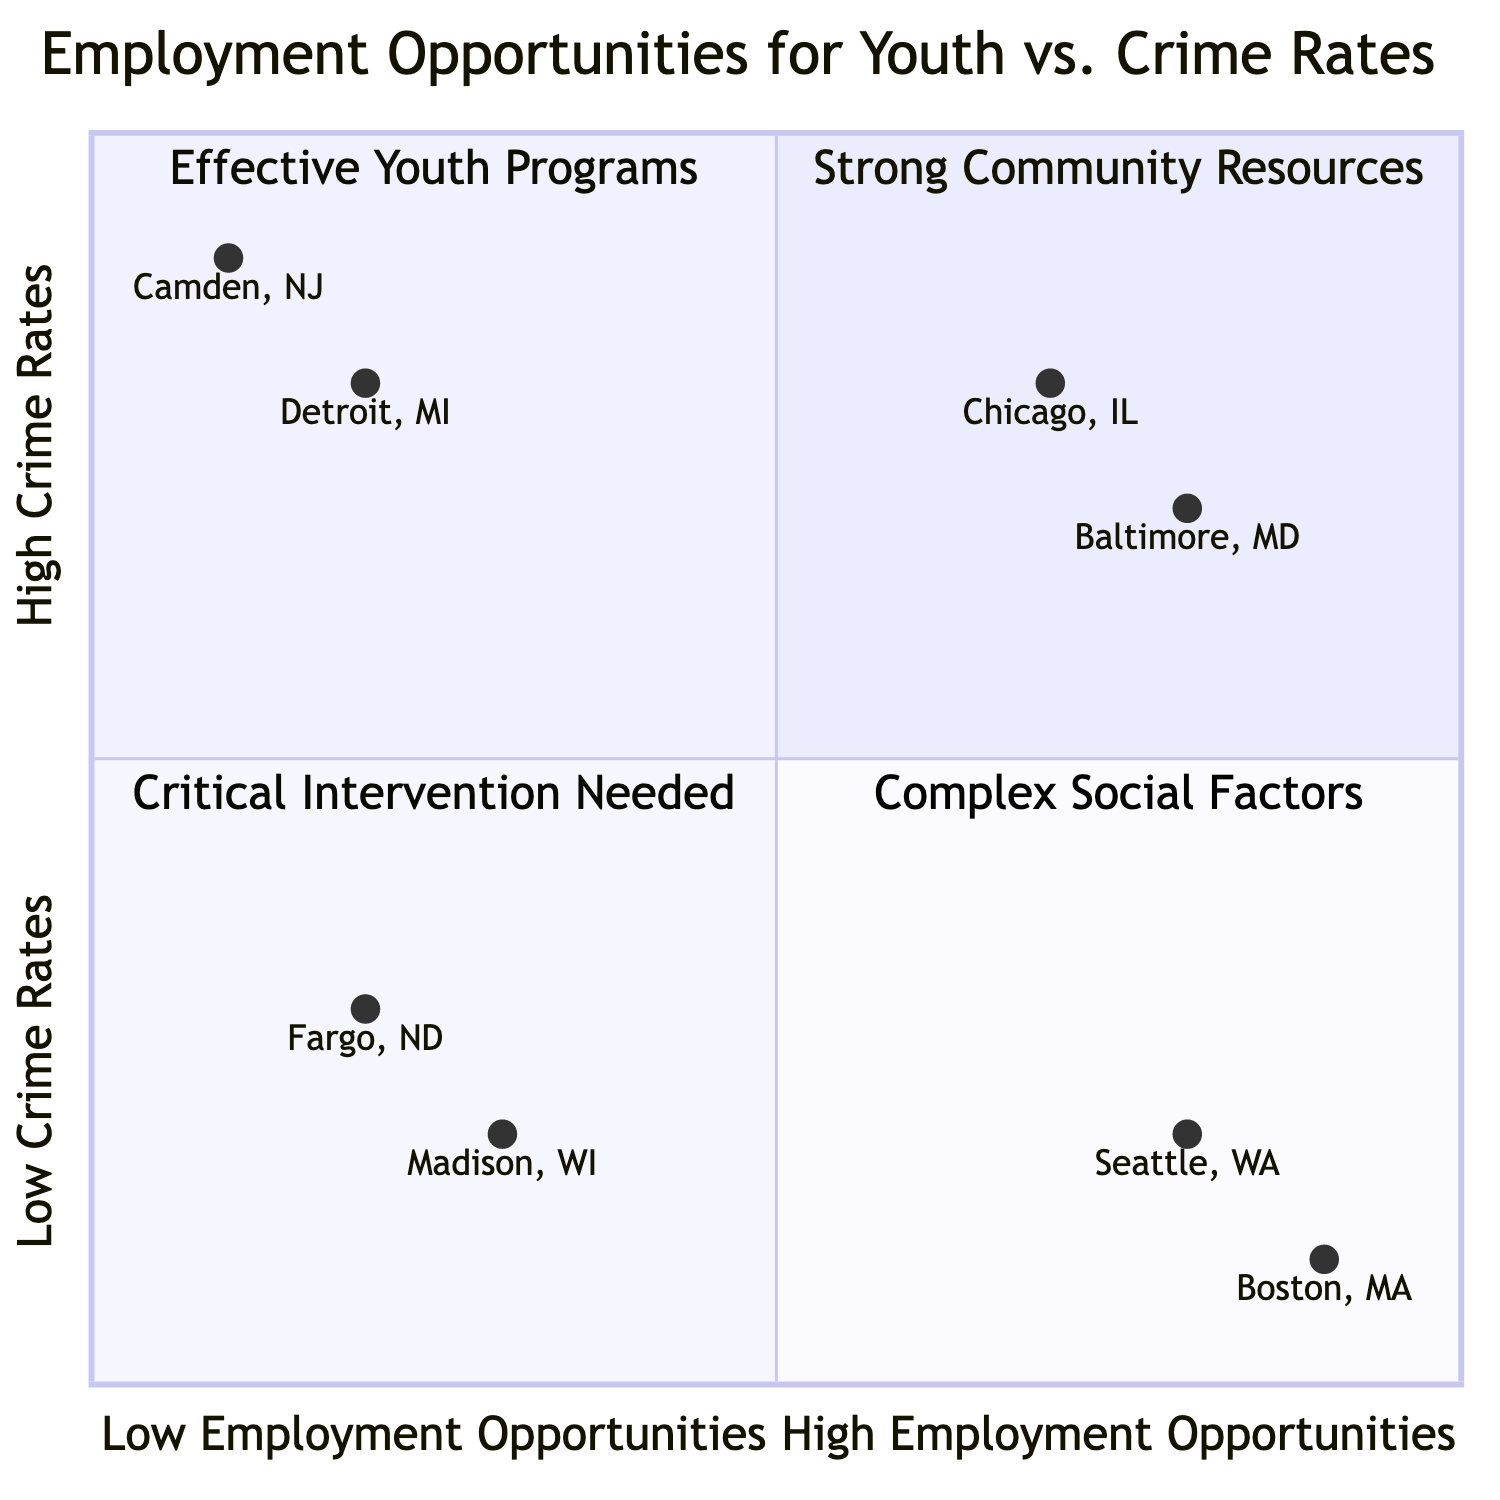What locations have high employment opportunities and low crime rates? The diagram indicates that Seattle, WA, and Boston, MA, fall into the quadrant with high employment opportunities and low crime rates, highlighting their effective youth employment programs.
Answer: Seattle, WA; Boston, MA How many areas fall into the "Low Employment Opportunities, High Crime Rates" quadrant? The diagram depicts two locations, Camden, NJ, and Detroit, MI, which are classified in the "Low Employment Opportunities, High Crime Rates" quadrant, indicating a critical need for intervention.
Answer: 2 Which city has the highest youth employment opportunities? Upon reviewing the quadrant chart, Boston, MA has the highest value on the x-axis among the listed locations, indicating its robust employment opportunities for youth.
Answer: Boston, MA Which locations exhibit complex social factors despite having high employment opportunities? The analysis shows that Chicago, IL, and Baltimore, MD are situated in the area with high employment opportunities but also experience high crime rates, suggesting complexity in social dynamics.
Answer: Chicago, IL; Baltimore, MD What is the crime rate for Fargo, ND? The diagram locates Fargo, ND at approximately 0.3 on the y-axis, indicating a low crime rate.
Answer: 0.3 What are the supportive policies associated with Camden, NJ, as shown in the diagram? The chart lists "Camden Coalition of Healthcare Providers" and "Camden Violence Reduction Partnership" as supportive policies for Camden, NJ, which is crucial given its high crime rate and low youth employment opportunities.
Answer: Camden Coalition of Healthcare Providers; Camden Violence Reduction Partnership How many supportive policies are listed for the youth employment programs in Seattle, WA? The diagram identifies two supportive policies for Seattle, WA; namely, "Seattle Youth Ordinance 125992" and "City of Seattle's Pathways to Careers".
Answer: 2 Which quadrant includes locations with strong community resources but limited youth employment opportunities? According to the diagram, the quadrant titled "Strong Community Resources" contains areas like Fargo, ND, and Madison, WI that despite low employment opportunities, maintain lower crime rates due to strong community resources.
Answer: Strong Community Resources Which youth employment program is associated with Baltimore, MD? The diagram correctly associates "YouthWorks Summer Jobs" and "Baltimore Youth Apprenticeship Program" with Baltimore, MD, highlighting the focus on increasing employment opportunities for youth, even in areas with high crime rates.
Answer: YouthWorks Summer Jobs; Baltimore Youth Apprenticeship Program 